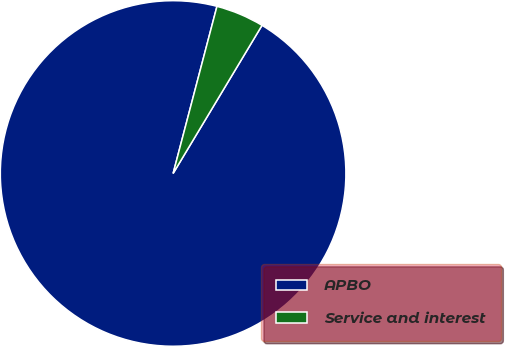Convert chart to OTSL. <chart><loc_0><loc_0><loc_500><loc_500><pie_chart><fcel>APBO<fcel>Service and interest<nl><fcel>95.48%<fcel>4.52%<nl></chart> 